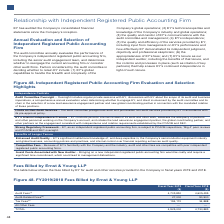According to Lam Research Corporation's financial document, What do the the audit fees represent? Based on the financial document, the answer is fees for professional services provided in connection with the audits of annual financial statements. Also, What do tax fees represent? Based on the financial document, the answer is fees for professional services for tax planning, tax compliance and review services related to foreign tax compliance and assistance with tax audits and appeals. Also, What do the audit-related fees represent? Based on the financial document, the answer is fees for assurance and related services that are reasonably related to the audit or review of the Company’s financial statements and are not reported above under “Audit Fees”. Also, can you calculate: What is the percentage change in the audit fees from 2018 to 2019? To answer this question, I need to perform calculations using the financial data. The calculation is: (4,703,830-4,605,495)/4,605,495, which equals 2.14 (percentage). This is based on the information: "Audit Fees (1) 4,703,830 4,605,495 Audit Fees (1) 4,703,830 4,605,495..." The key data points involved are: 4,605,495, 4,703,830. Also, can you calculate: What is the percentage change in the audit-related fees from 2018 to 2019? To answer this question, I need to perform calculations using the financial data. The calculation is: (27,000-90,500)/90,500, which equals -70.17 (percentage). This is based on the information: "Audit-Related Fees (2) 27,000 90,500 Audit-Related Fees (2) 27,000 90,500..." The key data points involved are: 27,000, 90,500. Also, can you calculate: What is the percentage change in the total fees from 2018 to 2019? To answer this question, I need to perform calculations using the financial data. The calculation is: (4,925,000-4,730,883)/4,730,883, which equals 4.1 (percentage). This is based on the information: "TOTAL 4,925,000 4,730,883 TOTAL 4,925,000 4,730,883..." The key data points involved are: 4,730,883, 4,925,000. 